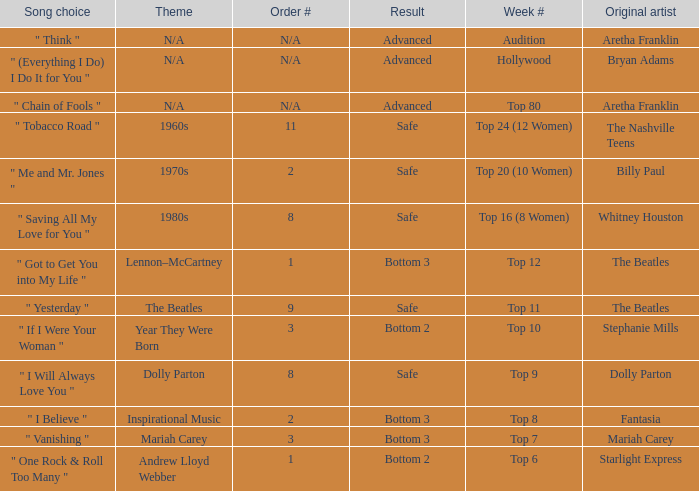Name the order number for the beatles and result is safe 9.0. 